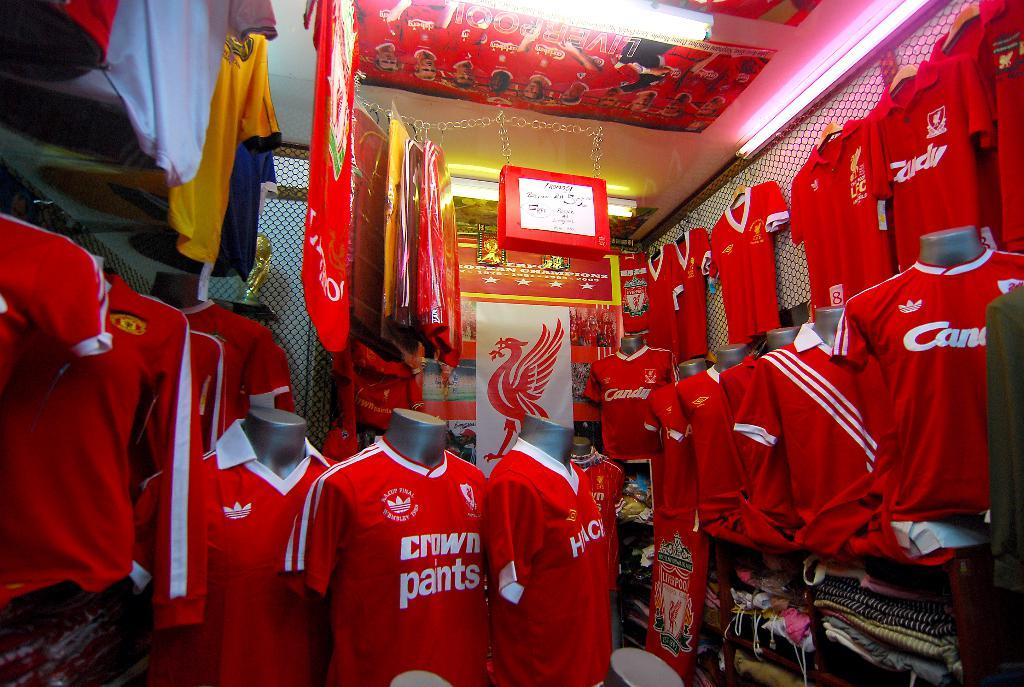<image>
Create a compact narrative representing the image presented. A store stocked full of red crown paints jerseys. 